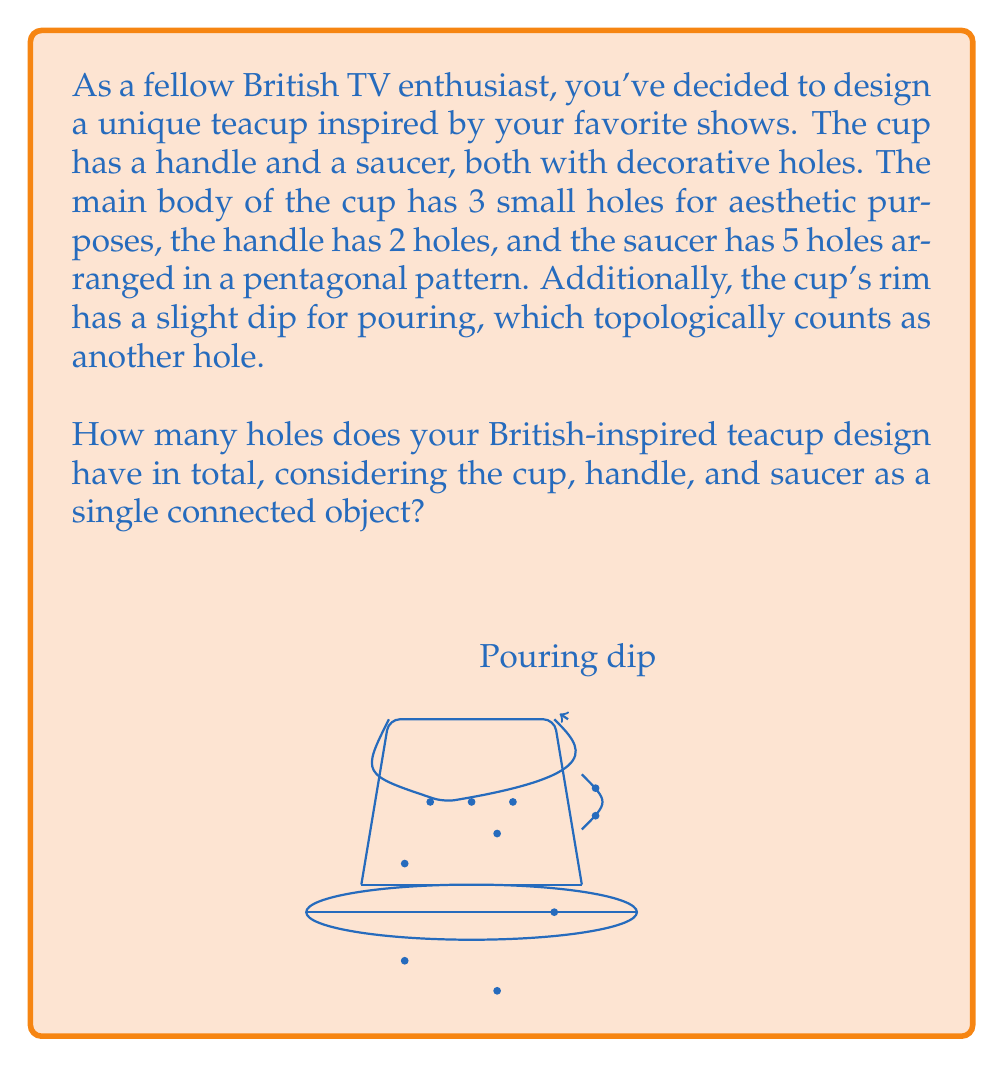Can you answer this question? To determine the total number of holes in the British-inspired teacup design, we need to count all the topological holes in the connected object. Let's break it down step-by-step:

1. Main body of the cup:
   - 3 small decorative holes
   - 1 hole for the pouring dip on the rim
   Total for main body: $3 + 1 = 4$ holes

2. Handle:
   - 2 decorative holes
   Total for handle: $2$ holes

3. Saucer:
   - 5 holes arranged in a pentagonal pattern
   Total for saucer: $5$ holes

4. Additional topological hole:
   - The space between the handle and the cup body creates one more topological hole
   Total additional: $1$ hole

Now, we sum up all the holes:

$$\text{Total holes} = \text{Main body} + \text{Handle} + \text{Saucer} + \text{Additional}$$
$$\text{Total holes} = 4 + 2 + 5 + 1 = 12$$

Therefore, the British-inspired teacup design has a total of 12 holes when considering the cup, handle, and saucer as a single connected object.
Answer: 12 holes 